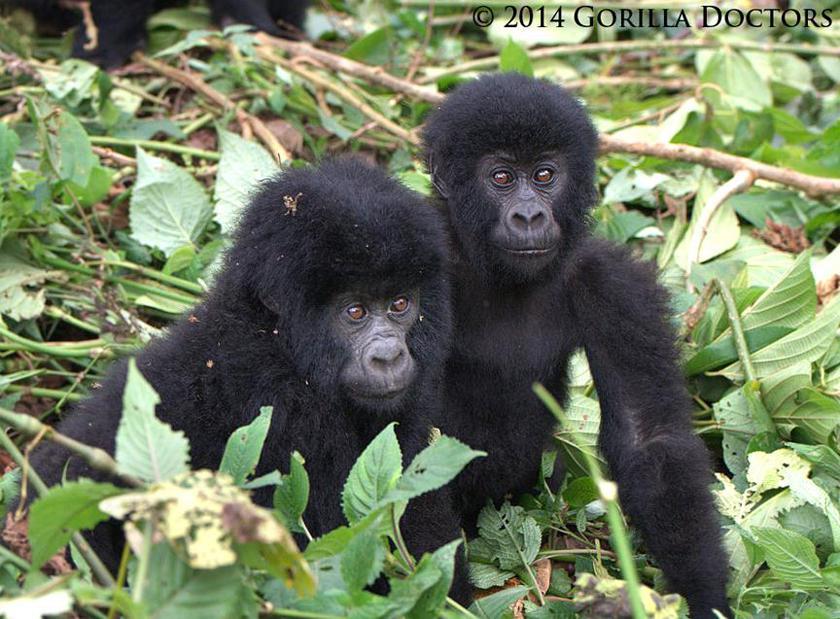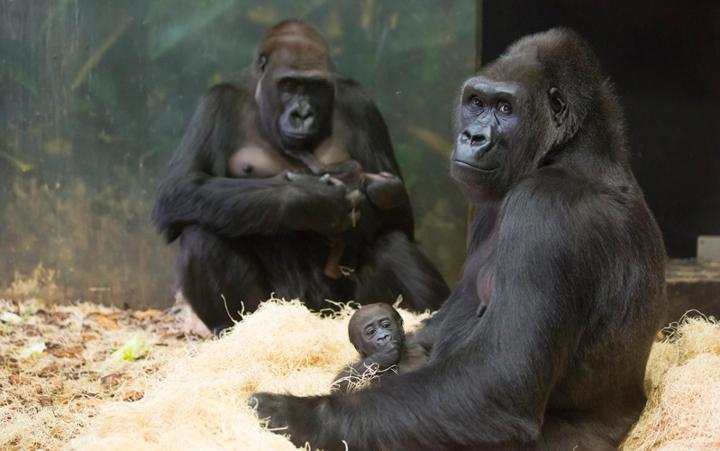The first image is the image on the left, the second image is the image on the right. Examine the images to the left and right. Is the description "The right image shows exactly two apes, posed with their heads horizontal to one another." accurate? Answer yes or no. No. The first image is the image on the left, the second image is the image on the right. Assess this claim about the two images: "There are two animals in the image on the left.". Correct or not? Answer yes or no. Yes. 